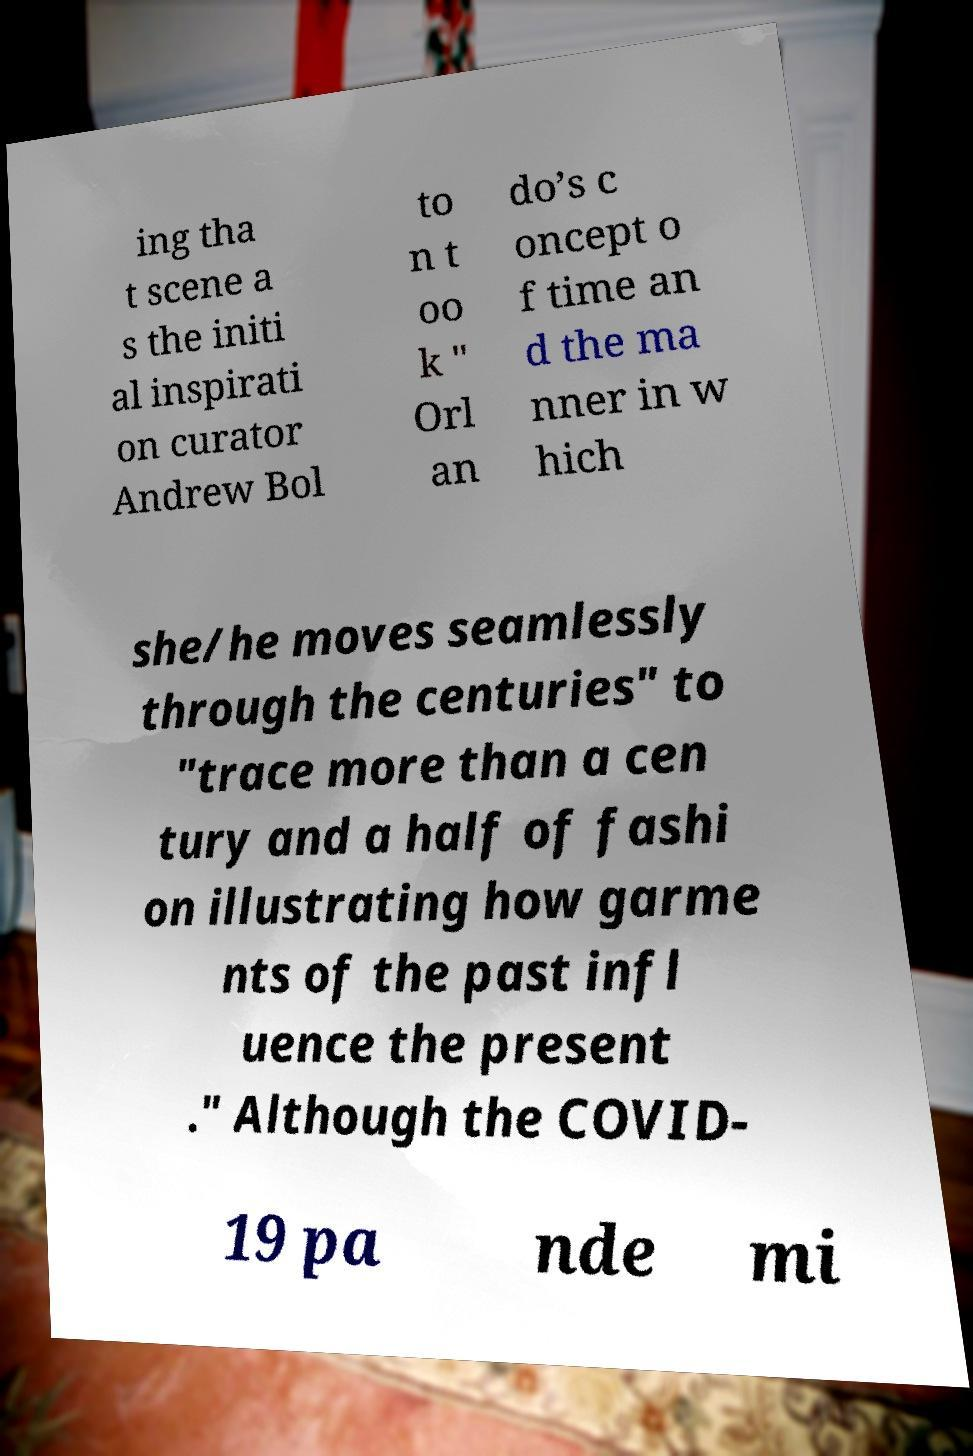There's text embedded in this image that I need extracted. Can you transcribe it verbatim? ing tha t scene a s the initi al inspirati on curator Andrew Bol to n t oo k " Orl an do’s c oncept o f time an d the ma nner in w hich she/he moves seamlessly through the centuries" to "trace more than a cen tury and a half of fashi on illustrating how garme nts of the past infl uence the present ." Although the COVID- 19 pa nde mi 